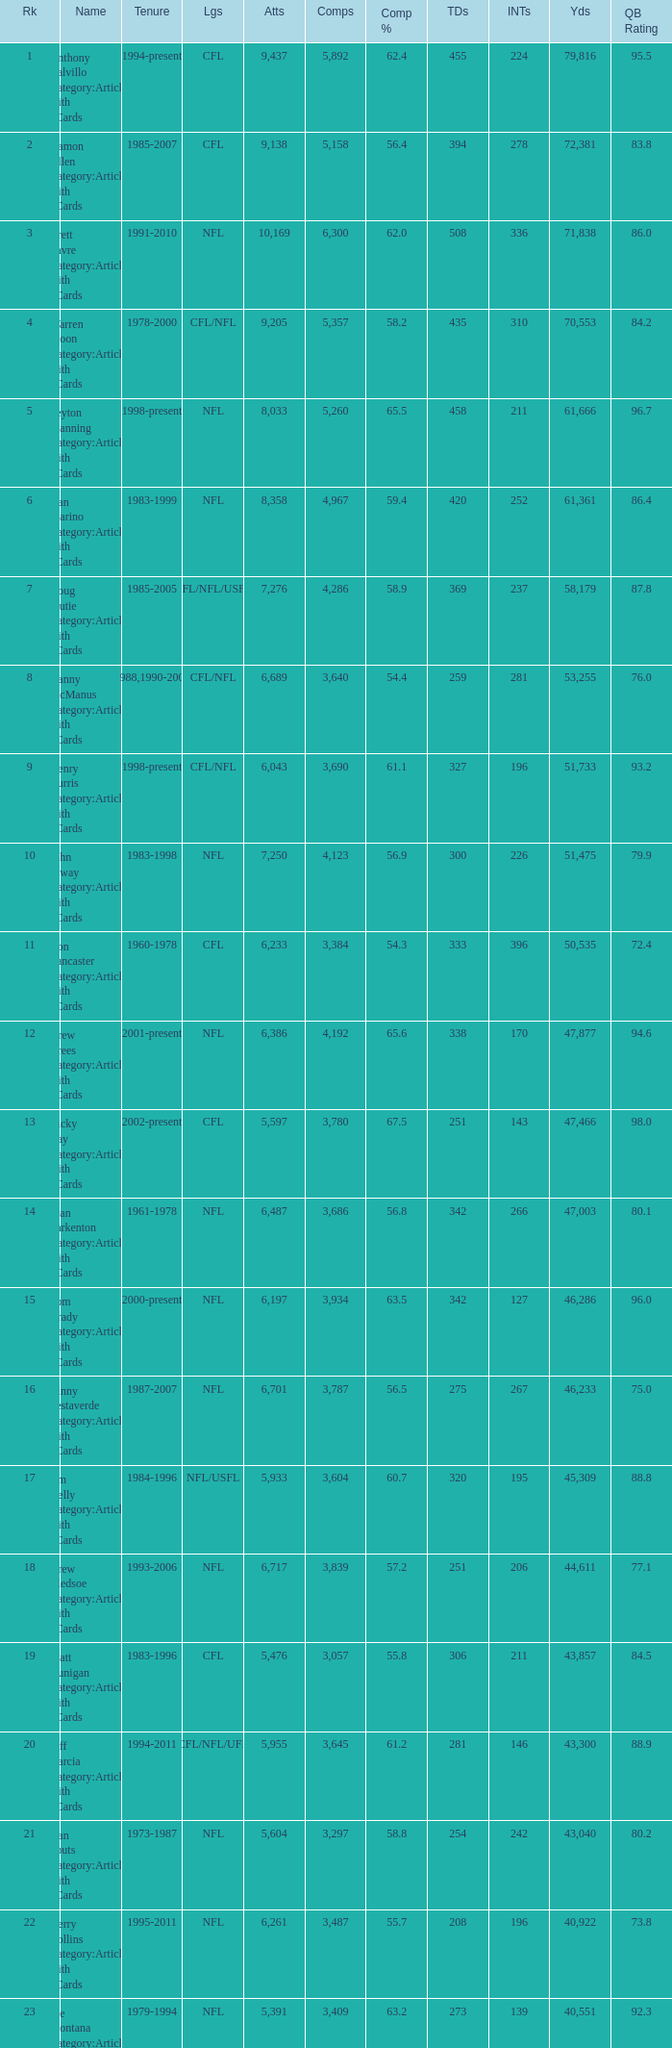What is the rank when there are more than 4,123 completion and the comp percentage is more than 65.6? None. Parse the table in full. {'header': ['Rk', 'Name', 'Tenure', 'Lgs', 'Atts', 'Comps', 'Comp %', 'TDs', 'INTs', 'Yds', 'QB Rating'], 'rows': [['1', 'Anthony Calvillo Category:Articles with hCards', '1994-present', 'CFL', '9,437', '5,892', '62.4', '455', '224', '79,816', '95.5'], ['2', 'Damon Allen Category:Articles with hCards', '1985-2007', 'CFL', '9,138', '5,158', '56.4', '394', '278', '72,381', '83.8'], ['3', 'Brett Favre Category:Articles with hCards', '1991-2010', 'NFL', '10,169', '6,300', '62.0', '508', '336', '71,838', '86.0'], ['4', 'Warren Moon Category:Articles with hCards', '1978-2000', 'CFL/NFL', '9,205', '5,357', '58.2', '435', '310', '70,553', '84.2'], ['5', 'Peyton Manning Category:Articles with hCards', '1998-present', 'NFL', '8,033', '5,260', '65.5', '458', '211', '61,666', '96.7'], ['6', 'Dan Marino Category:Articles with hCards', '1983-1999', 'NFL', '8,358', '4,967', '59.4', '420', '252', '61,361', '86.4'], ['7', 'Doug Flutie Category:Articles with hCards', '1985-2005', 'CFL/NFL/USFL', '7,276', '4,286', '58.9', '369', '237', '58,179', '87.8'], ['8', 'Danny McManus Category:Articles with hCards', '1988,1990-2006', 'CFL/NFL', '6,689', '3,640', '54.4', '259', '281', '53,255', '76.0'], ['9', 'Henry Burris Category:Articles with hCards', '1998-present', 'CFL/NFL', '6,043', '3,690', '61.1', '327', '196', '51,733', '93.2'], ['10', 'John Elway Category:Articles with hCards', '1983-1998', 'NFL', '7,250', '4,123', '56.9', '300', '226', '51,475', '79.9'], ['11', 'Ron Lancaster Category:Articles with hCards', '1960-1978', 'CFL', '6,233', '3,384', '54.3', '333', '396', '50,535', '72.4'], ['12', 'Drew Brees Category:Articles with hCards', '2001-present', 'NFL', '6,386', '4,192', '65.6', '338', '170', '47,877', '94.6'], ['13', 'Ricky Ray Category:Articles with hCards', '2002-present', 'CFL', '5,597', '3,780', '67.5', '251', '143', '47,466', '98.0'], ['14', 'Fran Tarkenton Category:Articles with hCards', '1961-1978', 'NFL', '6,487', '3,686', '56.8', '342', '266', '47,003', '80.1'], ['15', 'Tom Brady Category:Articles with hCards', '2000-present', 'NFL', '6,197', '3,934', '63.5', '342', '127', '46,286', '96.0'], ['16', 'Vinny Testaverde Category:Articles with hCards', '1987-2007', 'NFL', '6,701', '3,787', '56.5', '275', '267', '46,233', '75.0'], ['17', 'Jim Kelly Category:Articles with hCards', '1984-1996', 'NFL/USFL', '5,933', '3,604', '60.7', '320', '195', '45,309', '88.8'], ['18', 'Drew Bledsoe Category:Articles with hCards', '1993-2006', 'NFL', '6,717', '3,839', '57.2', '251', '206', '44,611', '77.1'], ['19', 'Matt Dunigan Category:Articles with hCards', '1983-1996', 'CFL', '5,476', '3,057', '55.8', '306', '211', '43,857', '84.5'], ['20', 'Jeff Garcia Category:Articles with hCards', '1994-2011', 'CFL/NFL/UFL', '5,955', '3,645', '61.2', '281', '146', '43,300', '88.9'], ['21', 'Dan Fouts Category:Articles with hCards', '1973-1987', 'NFL', '5,604', '3,297', '58.8', '254', '242', '43,040', '80.2'], ['22', 'Kerry Collins Category:Articles with hCards', '1995-2011', 'NFL', '6,261', '3,487', '55.7', '208', '196', '40,922', '73.8'], ['23', 'Joe Montana Category:Articles with hCards', '1979-1994', 'NFL', '5,391', '3,409', '63.2', '273', '139', '40,551', '92.3'], ['24', 'Tracy Ham Category:Articles with hCards', '1987-1999', 'CFL', '4,945', '2,670', '54.0', '284', '164', '40,534', '86.6'], ['25', 'Johnny Unitas Category:Articles with hCards', '1956-1973', 'NFL', '5,186', '2,830', '54.6', '290', '253', '40,239', '78.2']]} 